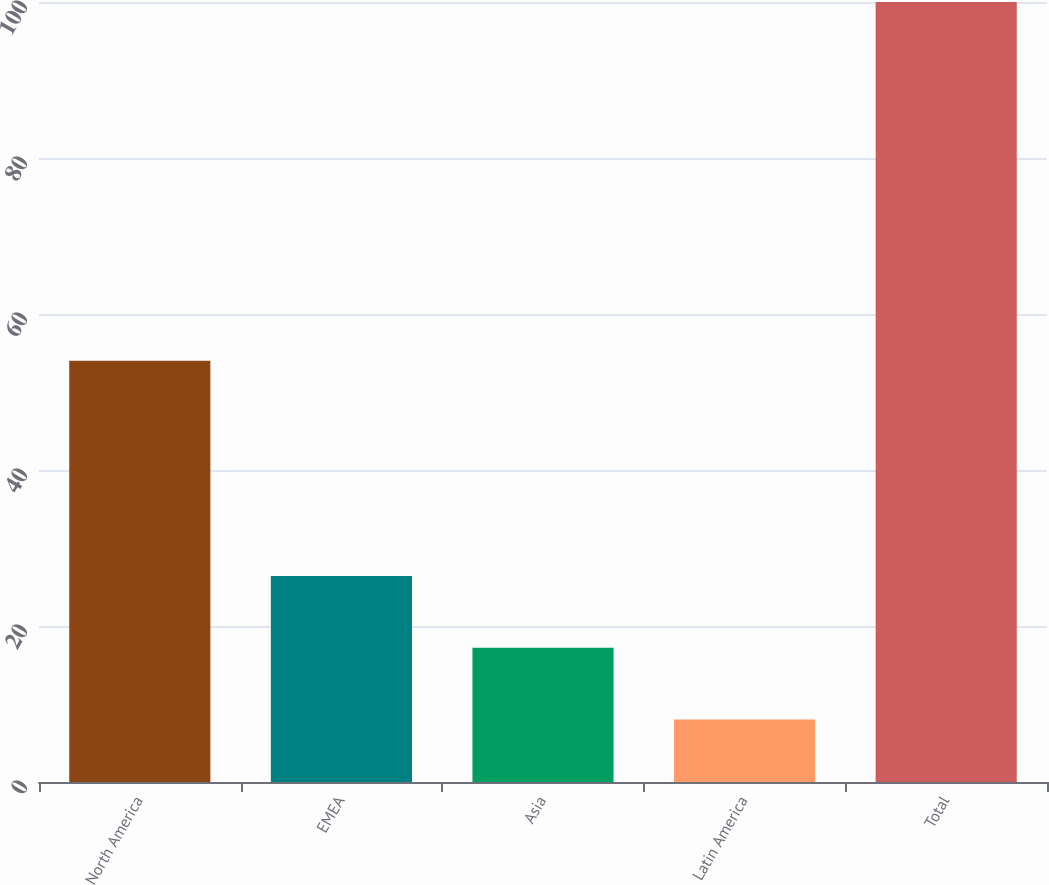<chart> <loc_0><loc_0><loc_500><loc_500><bar_chart><fcel>North America<fcel>EMEA<fcel>Asia<fcel>Latin America<fcel>Total<nl><fcel>54<fcel>26.4<fcel>17.2<fcel>8<fcel>100<nl></chart> 